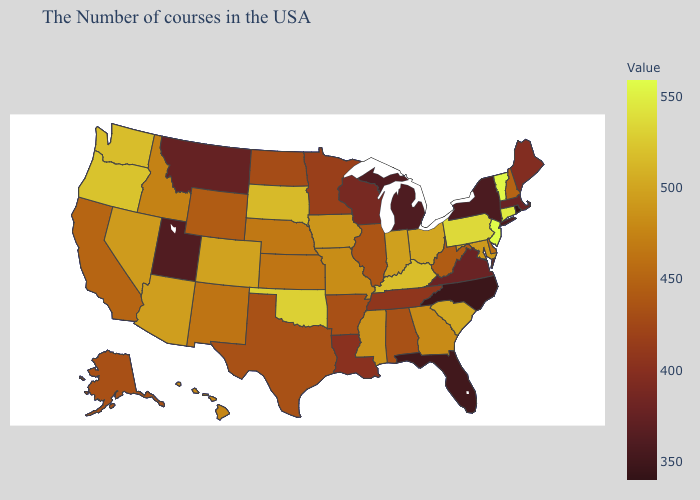Among the states that border Washington , which have the highest value?
Write a very short answer. Oregon. Among the states that border Arizona , which have the highest value?
Answer briefly. Colorado. Does the map have missing data?
Write a very short answer. No. Which states have the highest value in the USA?
Concise answer only. New Jersey. 